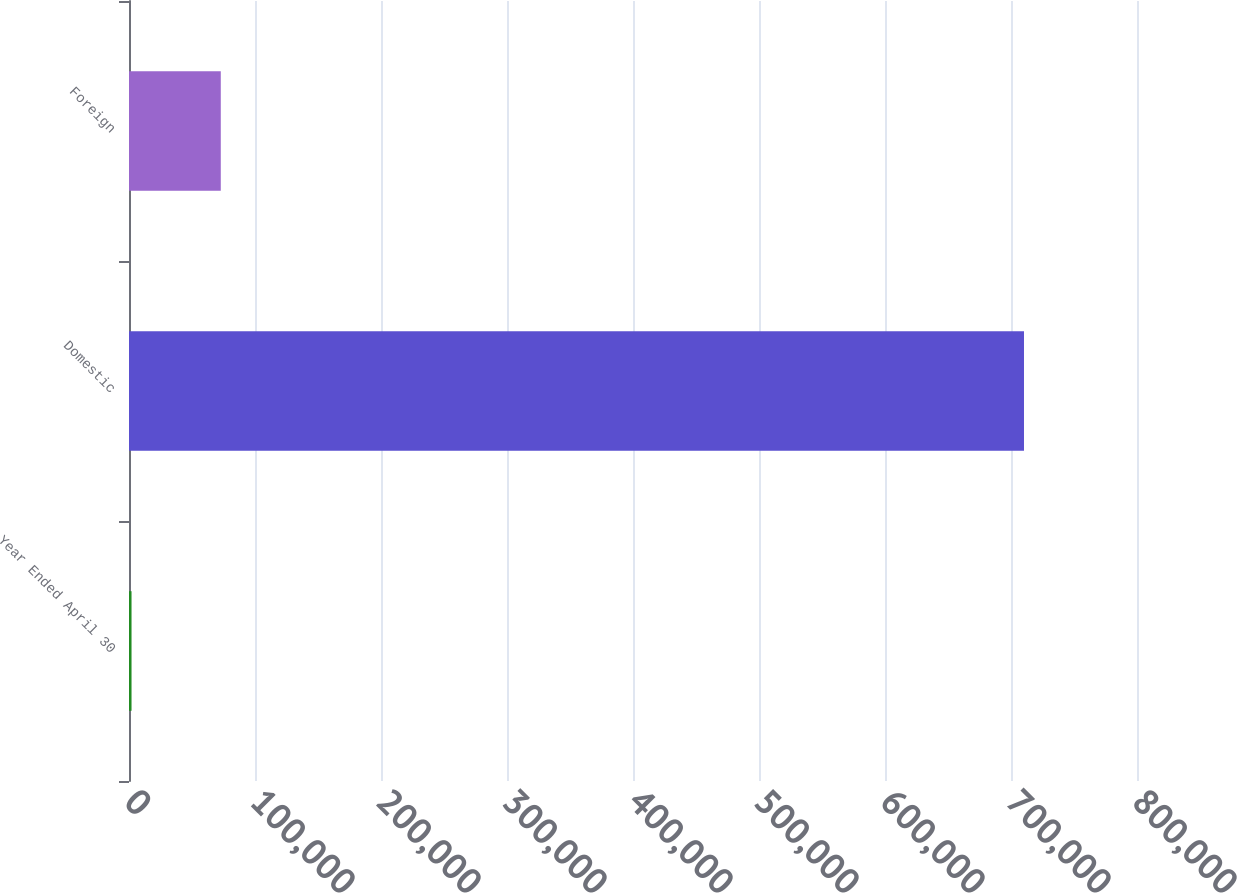<chart> <loc_0><loc_0><loc_500><loc_500><bar_chart><fcel>Year Ended April 30<fcel>Domestic<fcel>Foreign<nl><fcel>2008<fcel>710312<fcel>72838.4<nl></chart> 